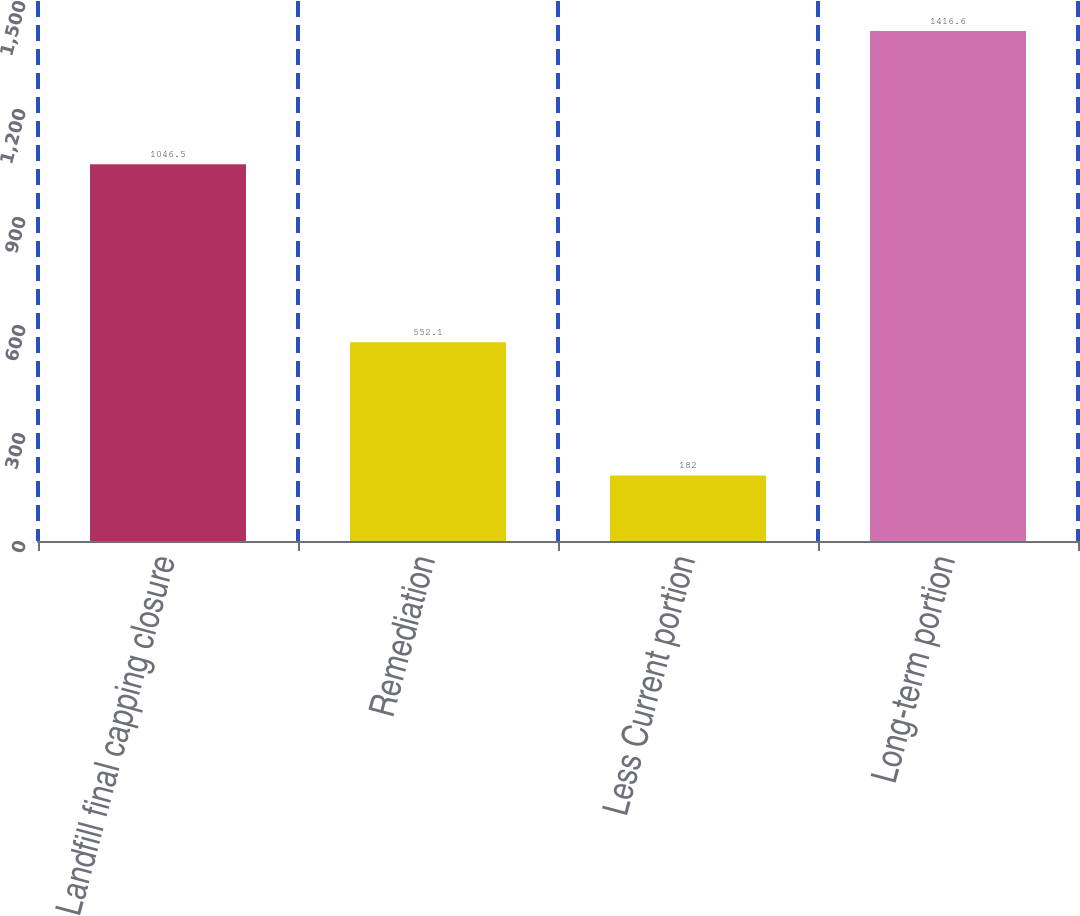<chart> <loc_0><loc_0><loc_500><loc_500><bar_chart><fcel>Landfill final capping closure<fcel>Remediation<fcel>Less Current portion<fcel>Long-term portion<nl><fcel>1046.5<fcel>552.1<fcel>182<fcel>1416.6<nl></chart> 